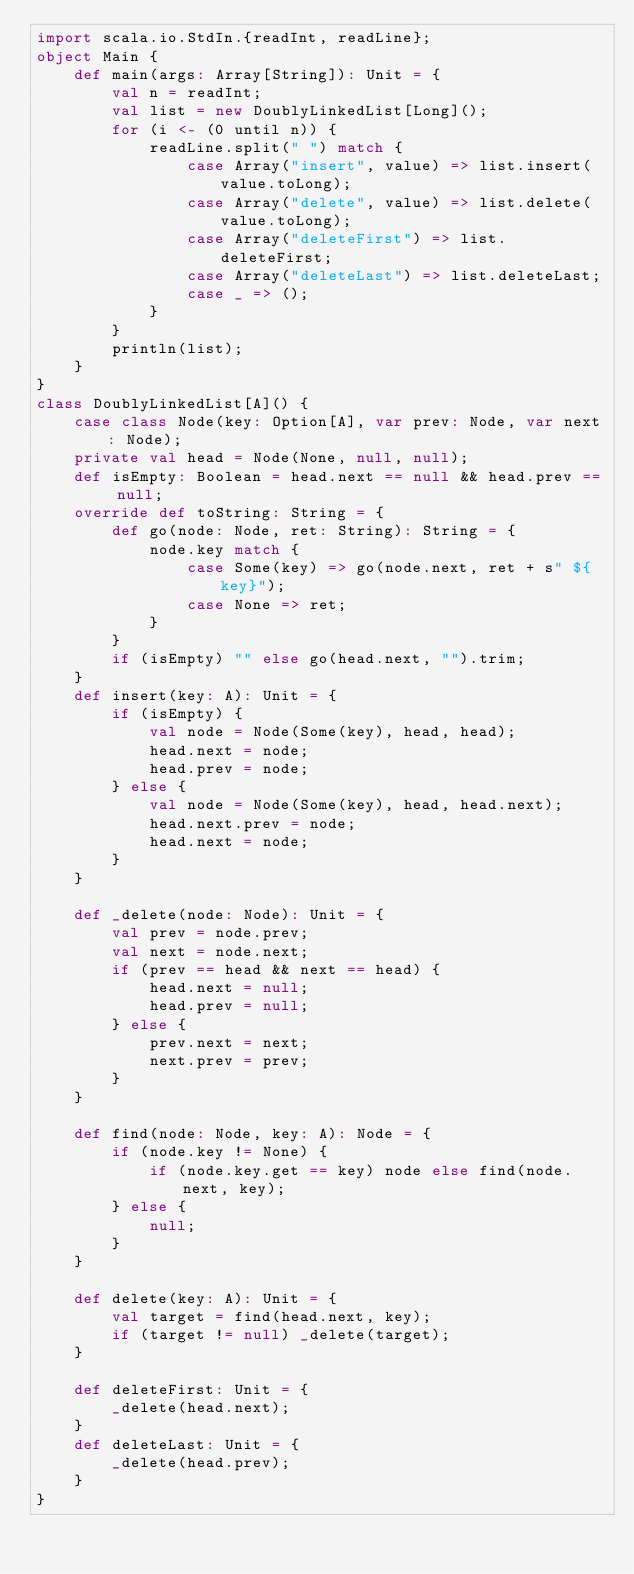<code> <loc_0><loc_0><loc_500><loc_500><_Scala_>import scala.io.StdIn.{readInt, readLine};
object Main {
    def main(args: Array[String]): Unit = {
        val n = readInt;
        val list = new DoublyLinkedList[Long]();
        for (i <- (0 until n)) {
            readLine.split(" ") match {
                case Array("insert", value) => list.insert(value.toLong);
                case Array("delete", value) => list.delete(value.toLong);
                case Array("deleteFirst") => list.deleteFirst;
                case Array("deleteLast") => list.deleteLast;
                case _ => ();
            }
        }
        println(list);
    }
}
class DoublyLinkedList[A]() {
    case class Node(key: Option[A], var prev: Node, var next: Node);
    private val head = Node(None, null, null);
    def isEmpty: Boolean = head.next == null && head.prev == null;
    override def toString: String = {
        def go(node: Node, ret: String): String = {
            node.key match {
                case Some(key) => go(node.next, ret + s" ${key}");
                case None => ret;
            }
        }
        if (isEmpty) "" else go(head.next, "").trim;
    }
    def insert(key: A): Unit = {
        if (isEmpty) {
            val node = Node(Some(key), head, head);
            head.next = node;
            head.prev = node;
        } else {
            val node = Node(Some(key), head, head.next);
            head.next.prev = node;
            head.next = node;
        }
    }
    
    def _delete(node: Node): Unit = {
        val prev = node.prev;
        val next = node.next;
        if (prev == head && next == head) {
            head.next = null;
            head.prev = null;
        } else {
            prev.next = next;
            next.prev = prev;
        }
    }
    
    def find(node: Node, key: A): Node = {
        if (node.key != None) {
            if (node.key.get == key) node else find(node.next, key);
        } else {
            null;
        }
    }
    
    def delete(key: A): Unit = {
        val target = find(head.next, key);
        if (target != null) _delete(target);
    }
    
    def deleteFirst: Unit = {
        _delete(head.next);
    }
    def deleteLast: Unit = {
        _delete(head.prev);
    }
}
</code> 